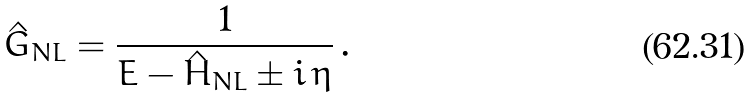<formula> <loc_0><loc_0><loc_500><loc_500>\hat { G } _ { N L } = \frac { 1 } { E - \hat { H } _ { N L } \pm i \, \eta } \, .</formula> 